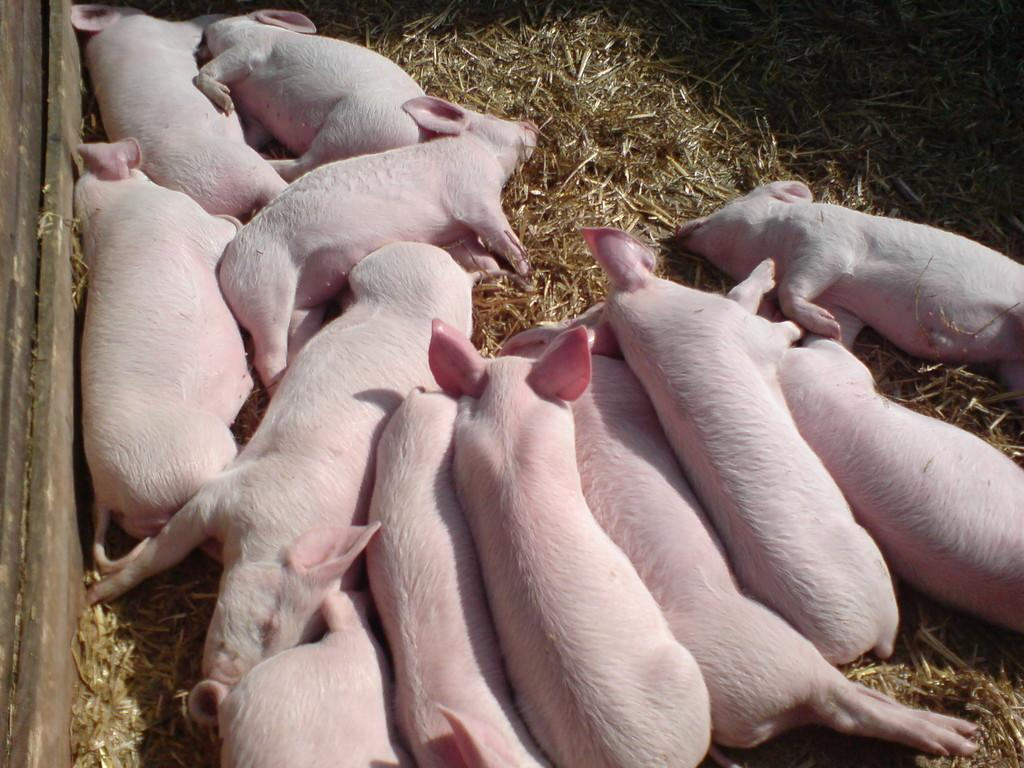What type of living organisms can be seen in the image? There are animals in the image. Where are the animals located? The animals are on the grass. What is the material of the wall on the left side of the image? The wall on the left side of the image is made of wood. What happens to the grass when the animals burst in the image? There is no indication in the image that the animals burst or that anything happens to the grass as a result. 